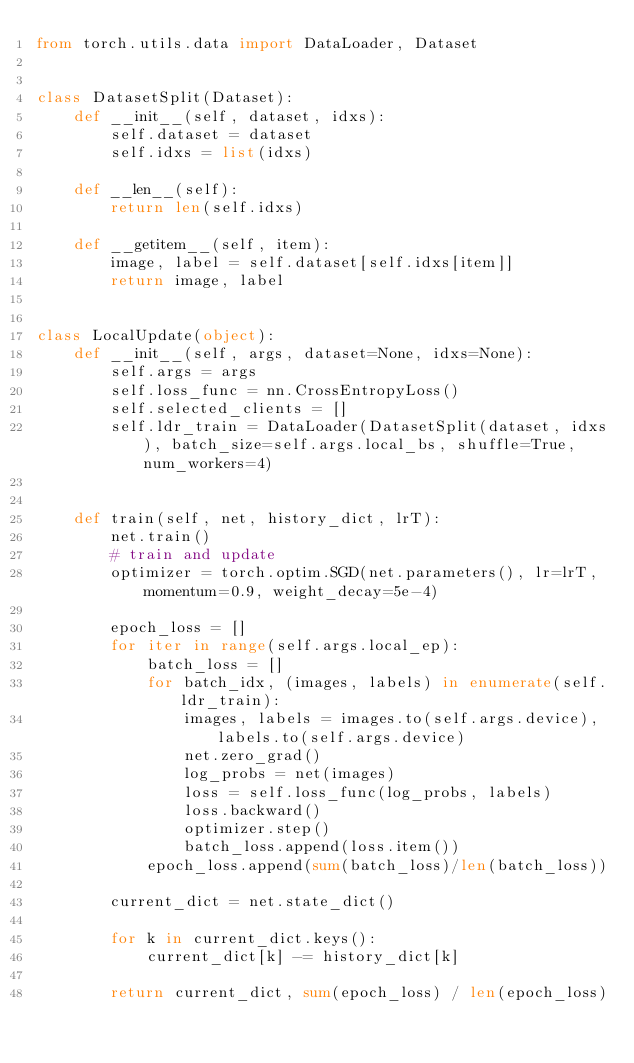<code> <loc_0><loc_0><loc_500><loc_500><_Python_>from torch.utils.data import DataLoader, Dataset


class DatasetSplit(Dataset):
    def __init__(self, dataset, idxs):
        self.dataset = dataset
        self.idxs = list(idxs)

    def __len__(self):
        return len(self.idxs)

    def __getitem__(self, item):
        image, label = self.dataset[self.idxs[item]]
        return image, label


class LocalUpdate(object):
    def __init__(self, args, dataset=None, idxs=None):
        self.args = args
        self.loss_func = nn.CrossEntropyLoss()
        self.selected_clients = []
        self.ldr_train = DataLoader(DatasetSplit(dataset, idxs), batch_size=self.args.local_bs, shuffle=True, num_workers=4)


    def train(self, net, history_dict, lrT):
        net.train()
        # train and update
        optimizer = torch.optim.SGD(net.parameters(), lr=lrT, momentum=0.9, weight_decay=5e-4)

        epoch_loss = []
        for iter in range(self.args.local_ep):
            batch_loss = []
            for batch_idx, (images, labels) in enumerate(self.ldr_train):
                images, labels = images.to(self.args.device), labels.to(self.args.device)
                net.zero_grad()
                log_probs = net(images)
                loss = self.loss_func(log_probs, labels)
                loss.backward()
                optimizer.step()
                batch_loss.append(loss.item())
            epoch_loss.append(sum(batch_loss)/len(batch_loss))
        
        current_dict = net.state_dict()

        for k in current_dict.keys():
            current_dict[k] -= history_dict[k]

        return current_dict, sum(epoch_loss) / len(epoch_loss)

</code> 